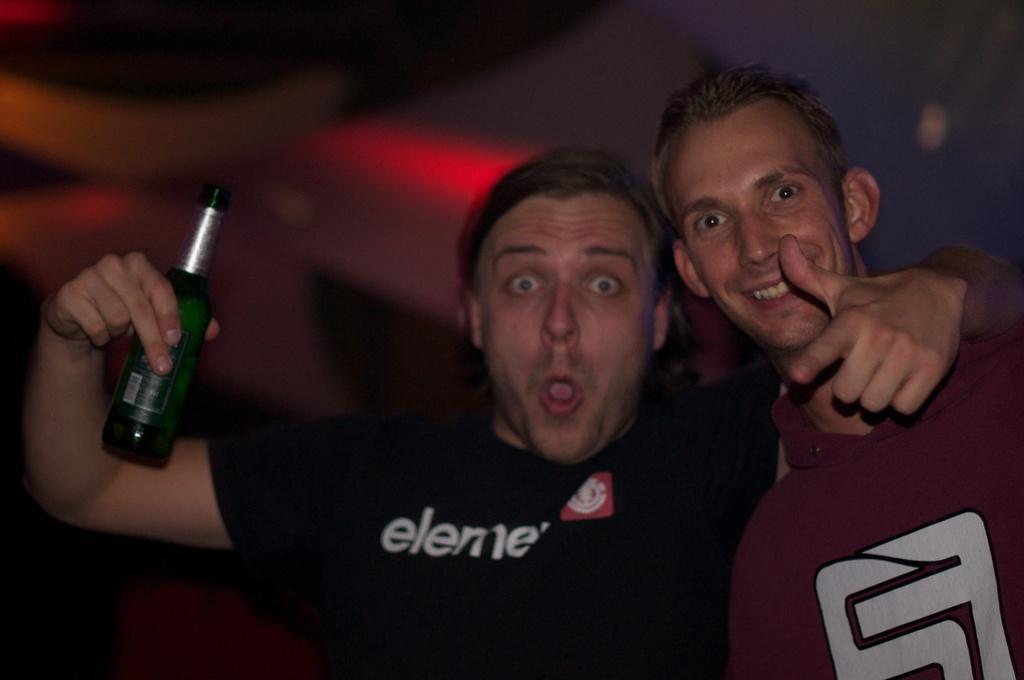How would you summarize this image in a sentence or two? This is the picture of a two persons. The man in black t shirt was holding a bottle, Behind the people there is a wall. 